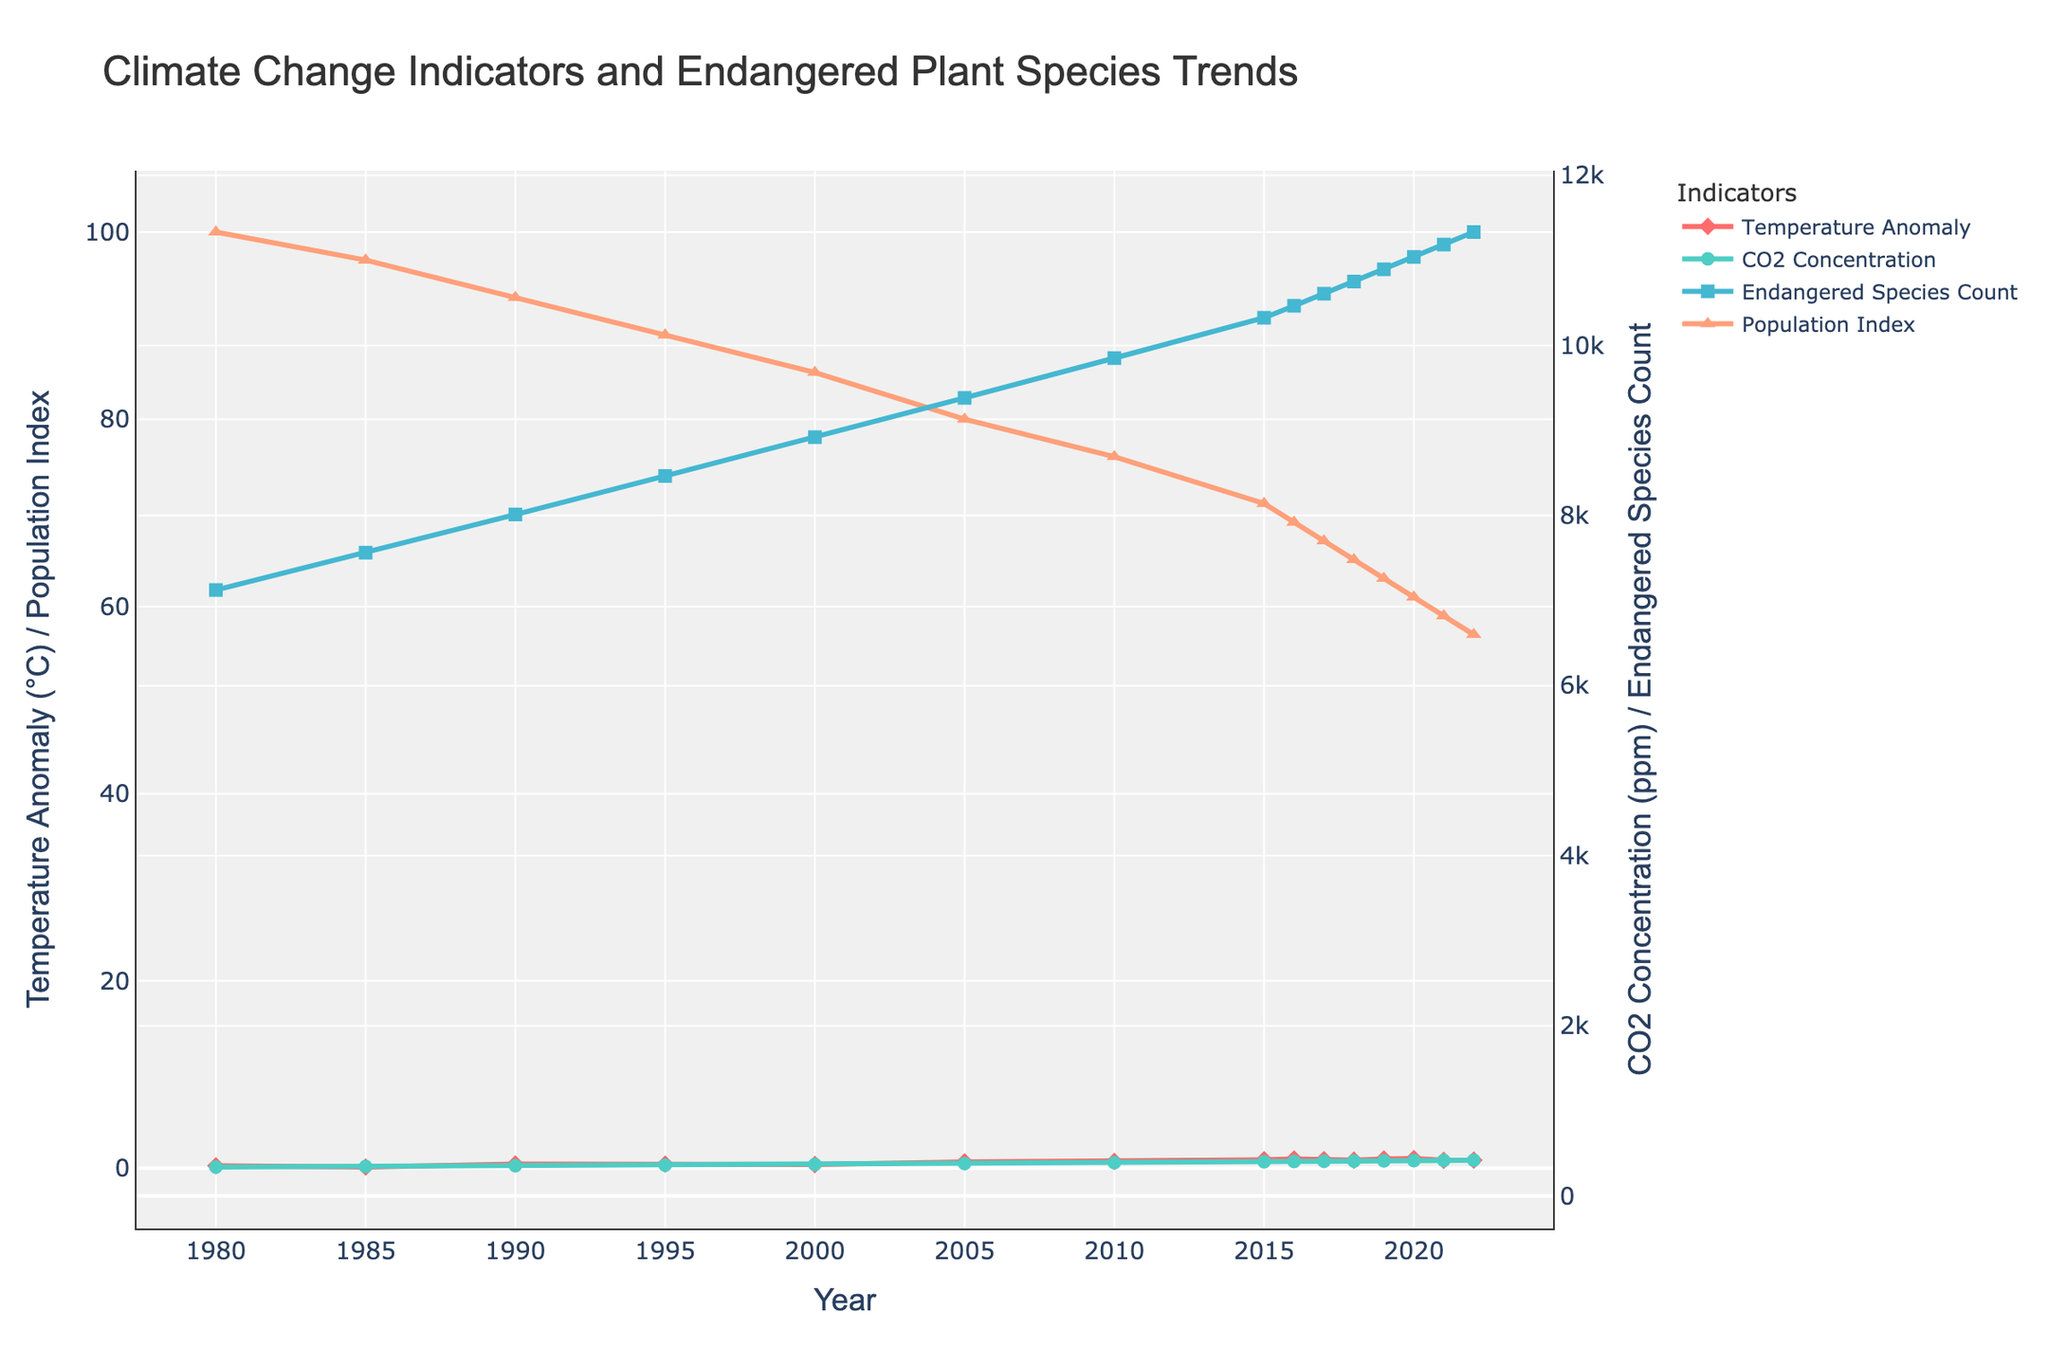What trend do you observe in the Global Temperature Anomaly and CO2 Concentration from 1980 to 2022? Both the Global Temperature Anomaly and CO2 Concentration show an increasing trend over the given period. The temperature anomaly rises from 0.26°C in 1980 to 0.86°C in 2022 while the CO2 concentration increases from 338.7 ppm to 418.9 ppm.
Answer: Increasing trend How has the Population Index of Key Endangered Plant Species changed from 1980 to 2022? The Population Index of Key Endangered Plant Species has been decreasing over the years. It started at 100 in 1980 and dropped to 57 by 2022. This indicates a consistent decline in the population index of key endangered plant species.
Answer: Decreasing trend Compare the Endangered Plant Species Count in 1980 and 2022. By how much has it changed? The Endangered Plant Species Count was 7,124 in 1980 and increased to 11,333 in 2022. The change is calculated as 11,333 - 7,124 = 4,209. Therefore, the count increased by 4,209 over this period.
Answer: Increased by 4,209 How does the change in Global Temperature Anomaly between 1980 and 2022 compare to the change in Population Index of Key Endangered Plant Species for the same period? The Global Temperature Anomaly increased from 0.26°C in 1980 to 0.86°C in 2022, a change of 0.86 - 0.26 = 0.6°C. The Population Index of Key Endangered Plant Species decreased from 100 to 57, a change of 57 - 100 = -43. Hence, the temperature anomaly increased by 0.6°C, while the population index decreased by 43 points.
Answer: Temperature increased by 0.6°C, Population Index decreased by 43 Which year had the highest Global Temperature Anomaly, and what was its value? The highest Global Temperature Anomaly was in 2020, with a value of 1.02°C.
Answer: 2020, 1.02°C What is the average CO2 Concentration for the years 2015 to 2022? The CO2 Concentrations for the years 2015 to 2022 are 400.8, 404.2, 406.6, 408.5, 411.4, 414.2, 416.5, and 418.9 ppm. The sum is 3281.1 ppm. The average is calculated as 3281.1 / 8 = 410.14 ppm.
Answer: 410.14 ppm By how much did the Endangered Plant Species Count increase between 1990 and 2000? The Endangered Plant Species Count was 8,012 in 1990 and increased to 8,921 in 2000. The increment is calculated as 8,921 - 8,012 = 909. Therefore, it increased by 909 over this period.
Answer: Increased by 909 In which year did the Population Index of Key Endangered Plant Species drop below 70 for the first time? The Population Index of Key Endangered Plant Species dropped below 70 for the first time in 2016, where the value was 69.
Answer: 2016 What relationship do you observe between the CO2 Concentration and the Endangered Plant Species Count? As the CO2 Concentration increases, the Endangered Plant Species Count also increases. This indicates a positive correlation between CO2 concentration and the number of endangered plant species counted over the years.
Answer: Positive correlation 